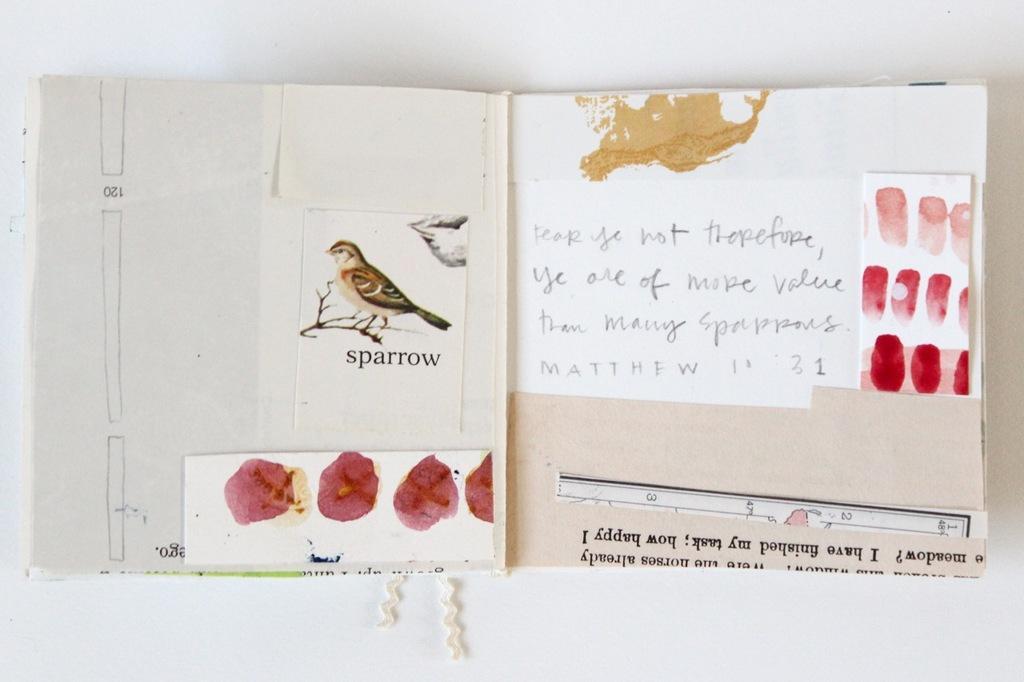Can you describe this image briefly? In this image I can see the white colored surface and on it I can see a book in which I can see few papers attached. I can see a bird on a tree branch which is brown, black and ash in color and few red colored marks. 